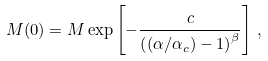Convert formula to latex. <formula><loc_0><loc_0><loc_500><loc_500>M ( 0 ) = M \exp \left [ - \frac { c } { \left ( ( \alpha / \alpha _ { c } ) - 1 \right ) ^ { \beta } } \right ] \, ,</formula> 